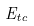<formula> <loc_0><loc_0><loc_500><loc_500>E _ { t c }</formula> 